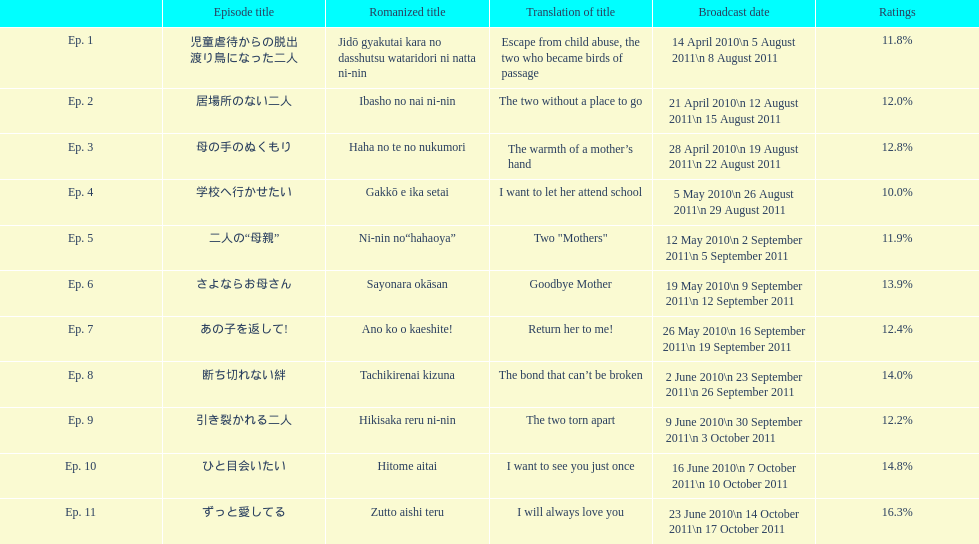Write the full table. {'header': ['', 'Episode title', 'Romanized title', 'Translation of title', 'Broadcast date', 'Ratings'], 'rows': [['Ep. 1', '児童虐待からの脱出 渡り鳥になった二人', 'Jidō gyakutai kara no dasshutsu wataridori ni natta ni-nin', 'Escape from child abuse, the two who became birds of passage', '14 April 2010\\n 5 August 2011\\n 8 August 2011', '11.8%'], ['Ep. 2', '居場所のない二人', 'Ibasho no nai ni-nin', 'The two without a place to go', '21 April 2010\\n 12 August 2011\\n 15 August 2011', '12.0%'], ['Ep. 3', '母の手のぬくもり', 'Haha no te no nukumori', 'The warmth of a mother’s hand', '28 April 2010\\n 19 August 2011\\n 22 August 2011', '12.8%'], ['Ep. 4', '学校へ行かせたい', 'Gakkō e ika setai', 'I want to let her attend school', '5 May 2010\\n 26 August 2011\\n 29 August 2011', '10.0%'], ['Ep. 5', '二人の“母親”', 'Ni-nin no“hahaoya”', 'Two "Mothers"', '12 May 2010\\n 2 September 2011\\n 5 September 2011', '11.9%'], ['Ep. 6', 'さよならお母さん', 'Sayonara okāsan', 'Goodbye Mother', '19 May 2010\\n 9 September 2011\\n 12 September 2011', '13.9%'], ['Ep. 7', 'あの子を返して!', 'Ano ko o kaeshite!', 'Return her to me!', '26 May 2010\\n 16 September 2011\\n 19 September 2011', '12.4%'], ['Ep. 8', '断ち切れない絆', 'Tachikirenai kizuna', 'The bond that can’t be broken', '2 June 2010\\n 23 September 2011\\n 26 September 2011', '14.0%'], ['Ep. 9', '引き裂かれる二人', 'Hikisaka reru ni-nin', 'The two torn apart', '9 June 2010\\n 30 September 2011\\n 3 October 2011', '12.2%'], ['Ep. 10', 'ひと目会いたい', 'Hitome aitai', 'I want to see you just once', '16 June 2010\\n 7 October 2011\\n 10 October 2011', '14.8%'], ['Ep. 11', 'ずっと愛してる', 'Zutto aishi teru', 'I will always love you', '23 June 2010\\n 14 October 2011\\n 17 October 2011', '16.3%']]} Other than the 10th episode, which other episode has a 14% rating? Ep. 8. 